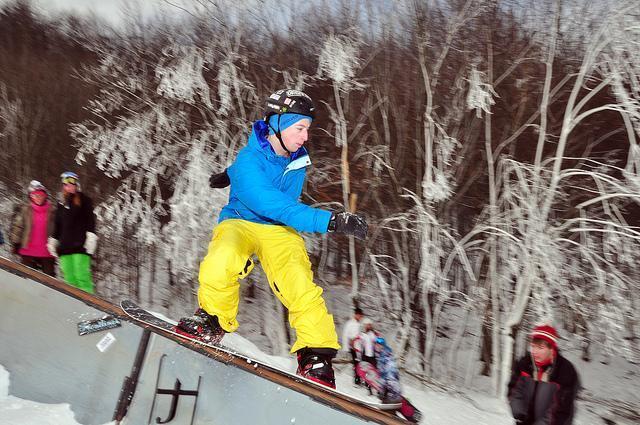How many people are in the photo?
Give a very brief answer. 4. How many elephants are in the ocean?
Give a very brief answer. 0. 